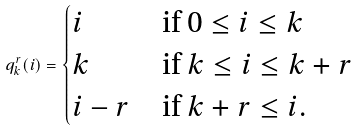<formula> <loc_0><loc_0><loc_500><loc_500>q _ { k } ^ { r } ( i ) = \begin{cases} i & \text {if $0 \leq i \leq k$} \\ k & \text {if $k \leq i \leq k+r$} \\ i - r & \text {if $k+r \leq i$} . \end{cases}</formula> 